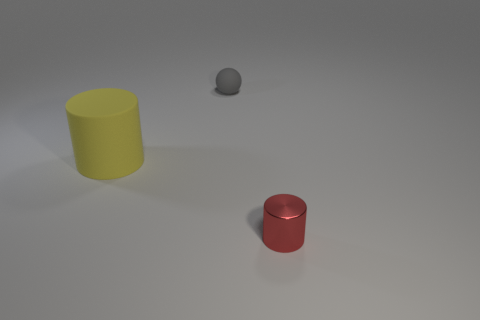Add 2 tiny rubber spheres. How many objects exist? 5 Subtract all spheres. How many objects are left? 2 Add 3 tiny matte spheres. How many tiny matte spheres are left? 4 Add 2 large yellow cylinders. How many large yellow cylinders exist? 3 Subtract 1 red cylinders. How many objects are left? 2 Subtract all tiny gray matte spheres. Subtract all red metallic cylinders. How many objects are left? 1 